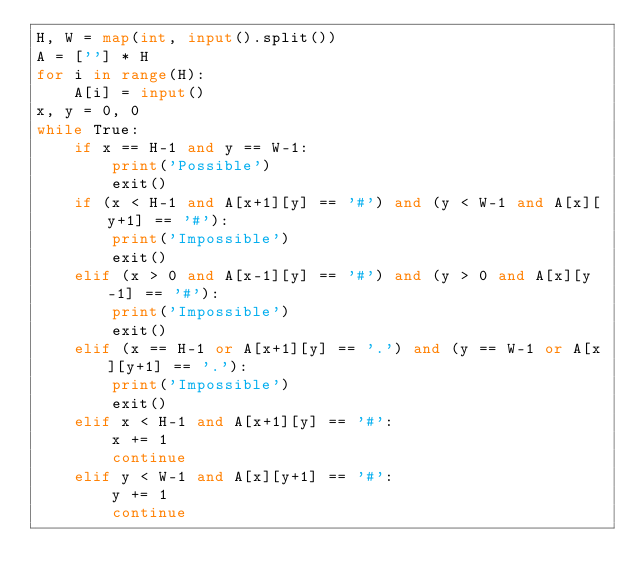<code> <loc_0><loc_0><loc_500><loc_500><_Python_>H, W = map(int, input().split())
A = [''] * H
for i in range(H):
    A[i] = input()
x, y = 0, 0
while True:
    if x == H-1 and y == W-1:
        print('Possible')
        exit()
    if (x < H-1 and A[x+1][y] == '#') and (y < W-1 and A[x][y+1] == '#'):
        print('Impossible')
        exit()
    elif (x > 0 and A[x-1][y] == '#') and (y > 0 and A[x][y-1] == '#'):
        print('Impossible')
        exit()
    elif (x == H-1 or A[x+1][y] == '.') and (y == W-1 or A[x][y+1] == '.'):
        print('Impossible')
        exit()
    elif x < H-1 and A[x+1][y] == '#':
        x += 1
        continue
    elif y < W-1 and A[x][y+1] == '#':
        y += 1
        continue</code> 